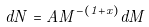Convert formula to latex. <formula><loc_0><loc_0><loc_500><loc_500>d N = A M ^ { - ( 1 + x ) } d M</formula> 